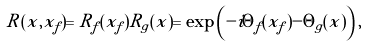<formula> <loc_0><loc_0><loc_500><loc_500>R ( x , x _ { f } ) = R _ { f } ( x _ { f } ) R _ { g } ( x ) = \exp \left ( - i \Theta _ { f } ( x _ { f } ) - \Theta _ { g } ( x ) \right ) ,</formula> 